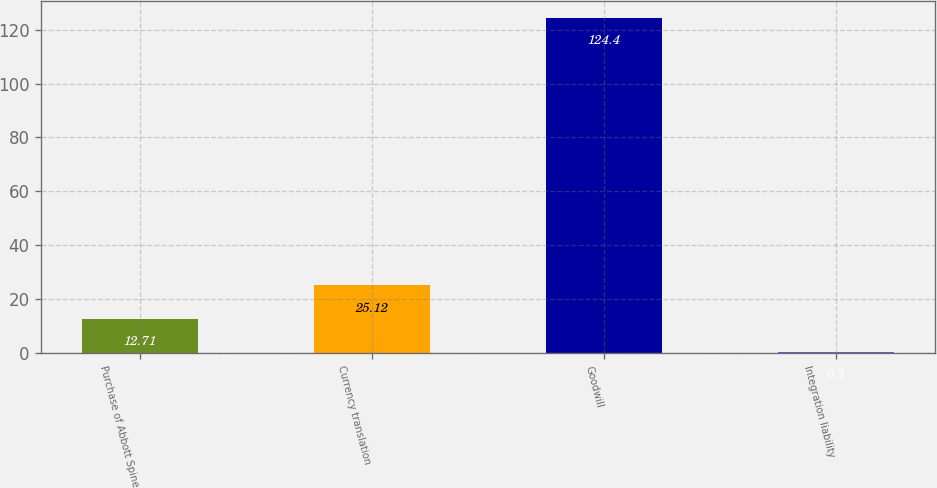Convert chart to OTSL. <chart><loc_0><loc_0><loc_500><loc_500><bar_chart><fcel>Purchase of Abbott Spine<fcel>Currency translation<fcel>Goodwill<fcel>Integration liability<nl><fcel>12.71<fcel>25.12<fcel>124.4<fcel>0.3<nl></chart> 